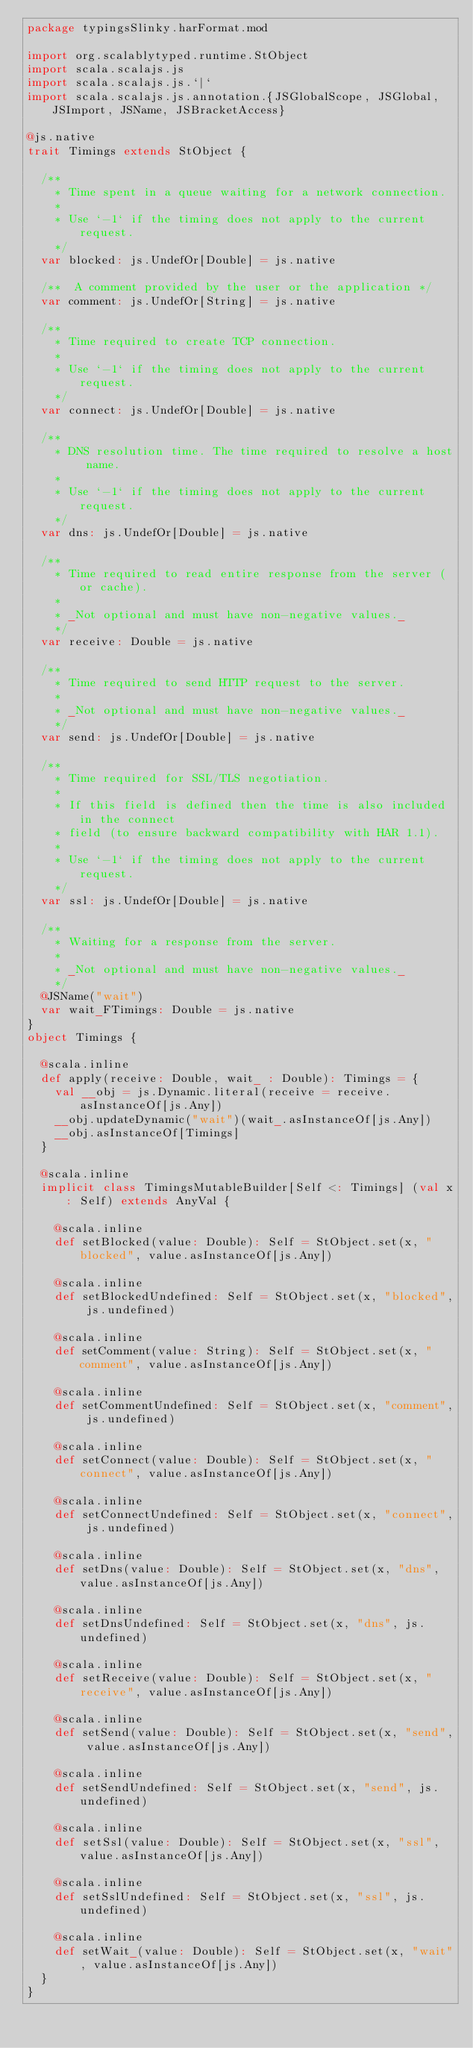<code> <loc_0><loc_0><loc_500><loc_500><_Scala_>package typingsSlinky.harFormat.mod

import org.scalablytyped.runtime.StObject
import scala.scalajs.js
import scala.scalajs.js.`|`
import scala.scalajs.js.annotation.{JSGlobalScope, JSGlobal, JSImport, JSName, JSBracketAccess}

@js.native
trait Timings extends StObject {
  
  /**
    * Time spent in a queue waiting for a network connection.
    *
    * Use `-1` if the timing does not apply to the current request.
    */
  var blocked: js.UndefOr[Double] = js.native
  
  /**  A comment provided by the user or the application */
  var comment: js.UndefOr[String] = js.native
  
  /**
    * Time required to create TCP connection.
    *
    * Use `-1` if the timing does not apply to the current request.
    */
  var connect: js.UndefOr[Double] = js.native
  
  /**
    * DNS resolution time. The time required to resolve a host name.
    *
    * Use `-1` if the timing does not apply to the current request.
    */
  var dns: js.UndefOr[Double] = js.native
  
  /**
    * Time required to read entire response from the server (or cache).
    *
    * _Not optional and must have non-negative values._
    */
  var receive: Double = js.native
  
  /**
    * Time required to send HTTP request to the server.
    *
    * _Not optional and must have non-negative values._
    */
  var send: js.UndefOr[Double] = js.native
  
  /**
    * Time required for SSL/TLS negotiation.
    *
    * If this field is defined then the time is also included in the connect
    * field (to ensure backward compatibility with HAR 1.1).
    *
    * Use `-1` if the timing does not apply to the current request.
    */
  var ssl: js.UndefOr[Double] = js.native
  
  /**
    * Waiting for a response from the server.
    *
    * _Not optional and must have non-negative values._
    */
  @JSName("wait")
  var wait_FTimings: Double = js.native
}
object Timings {
  
  @scala.inline
  def apply(receive: Double, wait_ : Double): Timings = {
    val __obj = js.Dynamic.literal(receive = receive.asInstanceOf[js.Any])
    __obj.updateDynamic("wait")(wait_.asInstanceOf[js.Any])
    __obj.asInstanceOf[Timings]
  }
  
  @scala.inline
  implicit class TimingsMutableBuilder[Self <: Timings] (val x: Self) extends AnyVal {
    
    @scala.inline
    def setBlocked(value: Double): Self = StObject.set(x, "blocked", value.asInstanceOf[js.Any])
    
    @scala.inline
    def setBlockedUndefined: Self = StObject.set(x, "blocked", js.undefined)
    
    @scala.inline
    def setComment(value: String): Self = StObject.set(x, "comment", value.asInstanceOf[js.Any])
    
    @scala.inline
    def setCommentUndefined: Self = StObject.set(x, "comment", js.undefined)
    
    @scala.inline
    def setConnect(value: Double): Self = StObject.set(x, "connect", value.asInstanceOf[js.Any])
    
    @scala.inline
    def setConnectUndefined: Self = StObject.set(x, "connect", js.undefined)
    
    @scala.inline
    def setDns(value: Double): Self = StObject.set(x, "dns", value.asInstanceOf[js.Any])
    
    @scala.inline
    def setDnsUndefined: Self = StObject.set(x, "dns", js.undefined)
    
    @scala.inline
    def setReceive(value: Double): Self = StObject.set(x, "receive", value.asInstanceOf[js.Any])
    
    @scala.inline
    def setSend(value: Double): Self = StObject.set(x, "send", value.asInstanceOf[js.Any])
    
    @scala.inline
    def setSendUndefined: Self = StObject.set(x, "send", js.undefined)
    
    @scala.inline
    def setSsl(value: Double): Self = StObject.set(x, "ssl", value.asInstanceOf[js.Any])
    
    @scala.inline
    def setSslUndefined: Self = StObject.set(x, "ssl", js.undefined)
    
    @scala.inline
    def setWait_(value: Double): Self = StObject.set(x, "wait", value.asInstanceOf[js.Any])
  }
}
</code> 